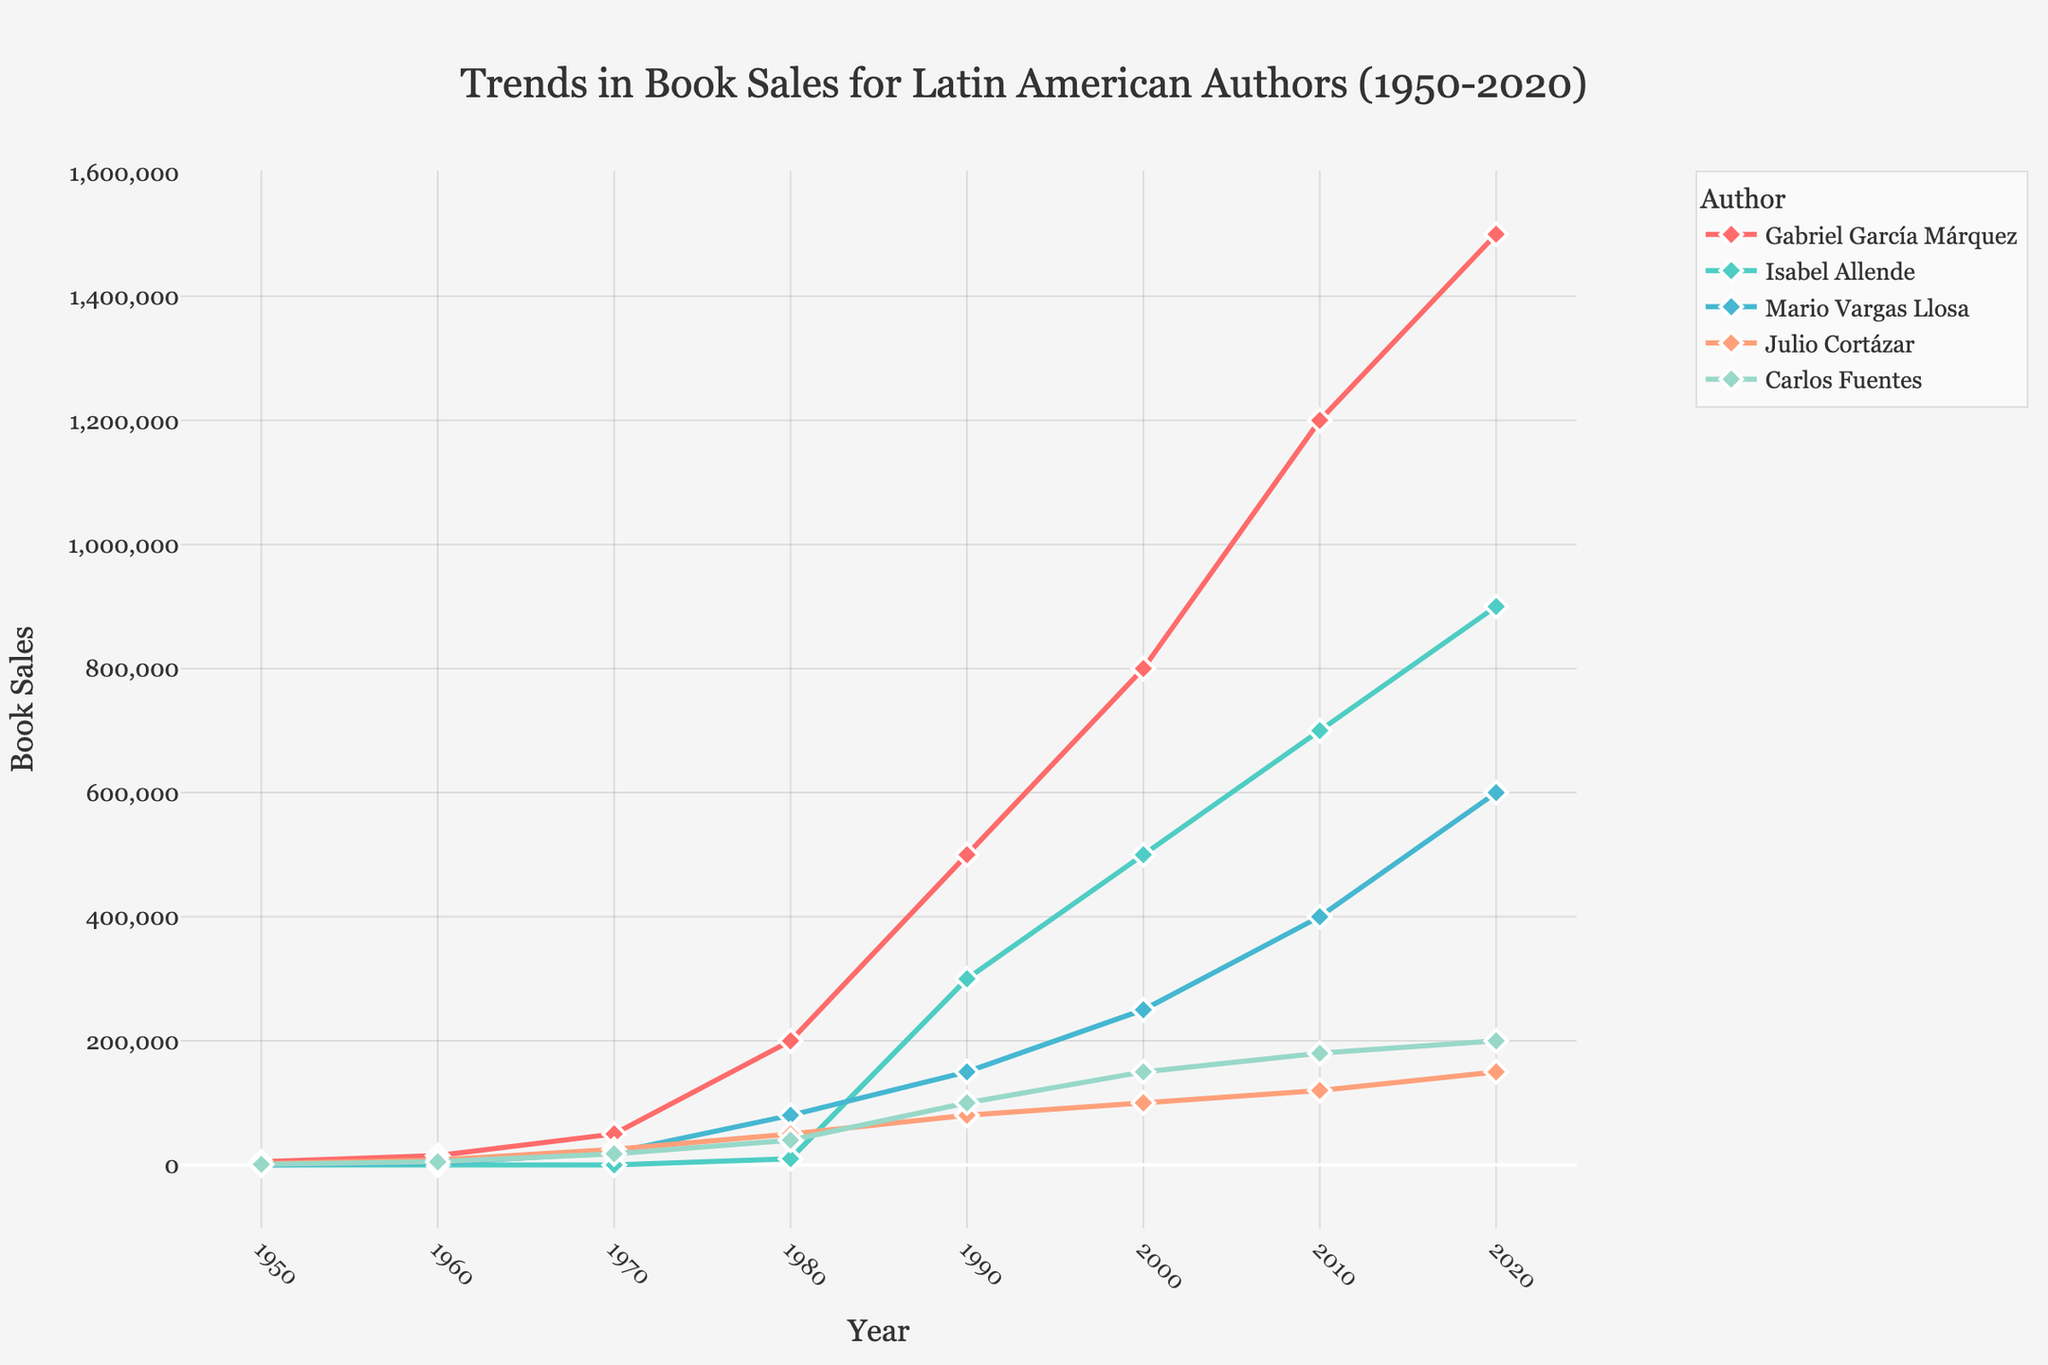What's the best-selling author in 2020? Gabriel García Márquez has the highest sales figure in 2020 with 1,500,000 book sales.
Answer: Gabriel García Márquez How much did Julio Cortázar's book sales increase from 1950 to 1980? Julio Cortázar's sales in 1950 were 2,000 and in 1980 they were 50,000. The increase is 50,000 - 2,000 = 48,000.
Answer: 48,000 Which author had the most significant sales increase between 1990 and 2000? Gabriel García Márquez's sales increased from 500,000 in 1990 to 800,000 in 2000. This increase of 300,000 is the largest among all authors during this period.
Answer: Gabriel García Márquez Compare the book sales of Isabel Allende and Mario Vargas Llosa in 2010. Who sold more? In 2010, Isabel Allende sold 700,000 books while Mario Vargas Llosa sold 400,000. Isabel Allende sold more.
Answer: Isabel Allende What is the average number of book sales for Carlos Fuentes in the given years? Summing Carlos Fuentes' sales across the years: 1,000 + 5,000 + 18,000 + 40,000 + 100,000 + 150,000 + 180,000 + 200,000 = 694,000. Dividing by the number of years (8) gives an average of 694,000 / 8 = 86,750.
Answer: 86,750 By how much did Gabriel García Márquez's sales surpass Julio Cortázar's sales in 1970? Gabriel García Márquez's sales in 1970 were 50,000 while Julio Cortázar's were 25,000. The difference is 50,000 - 25,000 = 25,000.
Answer: 25,000 Identify the trend for Mario Vargas Llosa's sales from 1950 to 2020. Mario Vargas Llosa's sales show a steady increase each decade: 0 in 1950, 3,000 in 1960, 20,000 in 1970, 80,000 in 1980, 150,000 in 1990, 250,000 in 2000, 400,000 in 2010, and 600,000 in 2020.
Answer: Steady increase What is the combined book sales for Isabel Allende and Carlos Fuentes in 1990? Isabel Allende's sales in 1990 were 300,000 and Carlos Fuentes' were 100,000. Combined, they sold 300,000 + 100,000 = 400,000 books.
Answer: 400,000 Compare the sales growth from 2000 to 2010 between Gabriel García Márquez and Isabel Allende. Gabriel García Márquez's sales grew from 800,000 in 2000 to 1,200,000 in 2010, an increase of 400,000. Isabel Allende's sales grew from 500,000 to 700,000, an increase of 200,000. Gabriel García Márquez had a greater sales growth.
Answer: Gabriel García Márquez Which author has the lowest book sales in 1980 and what is the sales figure? In 1980, Isabel Allende had the lowest sales figure with 10,000 book sales.
Answer: Isabel Allende, 10,000 